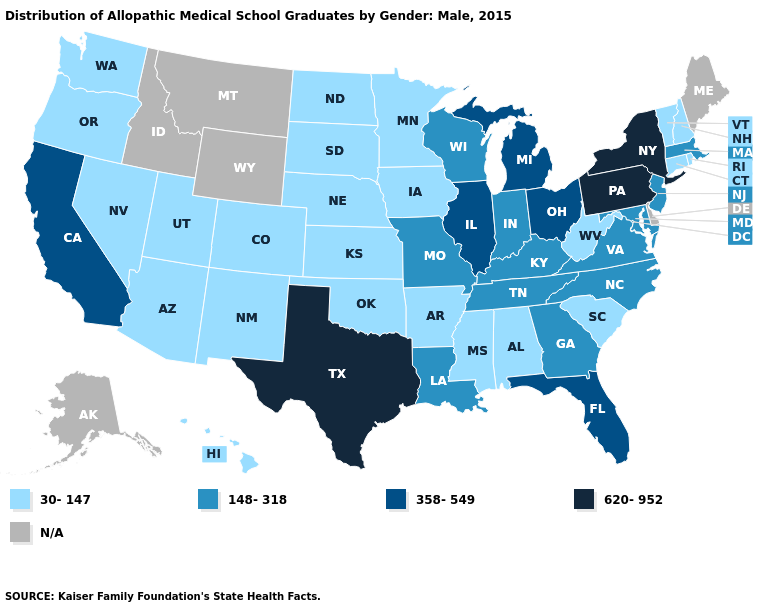Name the states that have a value in the range 358-549?
Concise answer only. California, Florida, Illinois, Michigan, Ohio. Name the states that have a value in the range 358-549?
Quick response, please. California, Florida, Illinois, Michigan, Ohio. Does Texas have the highest value in the South?
Give a very brief answer. Yes. What is the value of Connecticut?
Give a very brief answer. 30-147. What is the lowest value in the West?
Concise answer only. 30-147. Name the states that have a value in the range N/A?
Be succinct. Alaska, Delaware, Idaho, Maine, Montana, Wyoming. Which states hav the highest value in the Northeast?
Be succinct. New York, Pennsylvania. What is the value of Idaho?
Short answer required. N/A. Name the states that have a value in the range 148-318?
Quick response, please. Georgia, Indiana, Kentucky, Louisiana, Maryland, Massachusetts, Missouri, New Jersey, North Carolina, Tennessee, Virginia, Wisconsin. What is the lowest value in states that border Virginia?
Concise answer only. 30-147. Does the map have missing data?
Keep it brief. Yes. Name the states that have a value in the range N/A?
Concise answer only. Alaska, Delaware, Idaho, Maine, Montana, Wyoming. Name the states that have a value in the range 30-147?
Write a very short answer. Alabama, Arizona, Arkansas, Colorado, Connecticut, Hawaii, Iowa, Kansas, Minnesota, Mississippi, Nebraska, Nevada, New Hampshire, New Mexico, North Dakota, Oklahoma, Oregon, Rhode Island, South Carolina, South Dakota, Utah, Vermont, Washington, West Virginia. What is the lowest value in the MidWest?
Quick response, please. 30-147. 